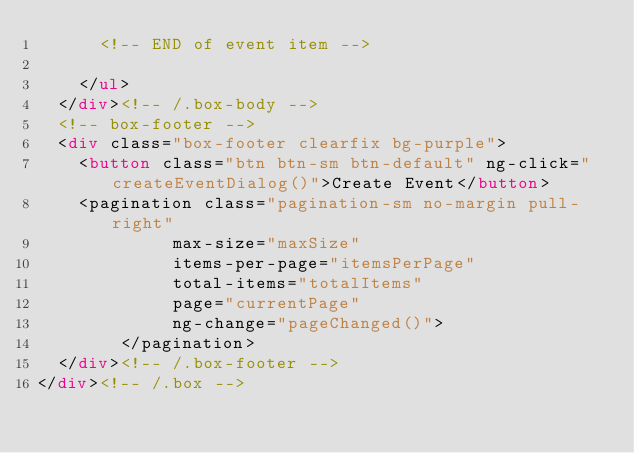<code> <loc_0><loc_0><loc_500><loc_500><_HTML_>      <!-- END of event item -->
      
    </ul>
  </div><!-- /.box-body -->
  <!-- box-footer -->
  <div class="box-footer clearfix bg-purple">
    <button class="btn btn-sm btn-default" ng-click="createEventDialog()">Create Event</button>
	<pagination class="pagination-sm no-margin pull-right"
			 max-size="maxSize"
			 items-per-page="itemsPerPage"
			 total-items="totalItems" 
			 page="currentPage" 
			 ng-change="pageChanged()">
		</pagination>
  </div><!-- /.box-footer -->
</div><!-- /.box -->
</code> 